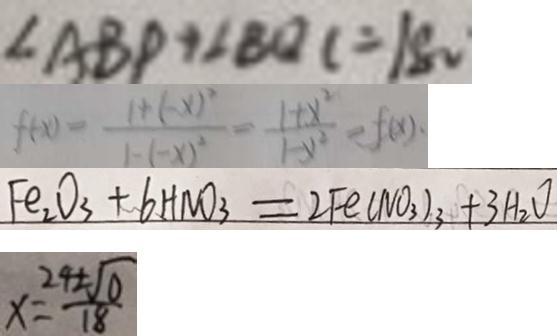Convert formula to latex. <formula><loc_0><loc_0><loc_500><loc_500>\angle A B P + \angle B Q C = 1 8 0 
 f ( x ) = \frac { 1 + ( - x ) ^ { 2 } } { 1 - ( - x ) ^ { 2 } } = \frac { 1 + x ^ { 2 } } { 1 - y ^ { 2 } } = f ( x ) . 
 F e _ { 2 } O _ { 3 } + 6 H N O _ { 3 } = 2 F e ( N O _ { 3 } ) _ { 3 } + 3 H _ { 2 } O 
 x = \frac { 2 4 \pm \sqrt { 0 } } { 1 8 }</formula> 